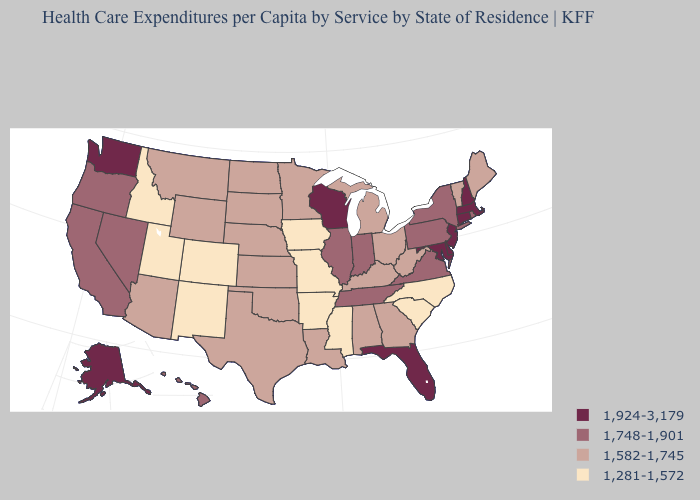Does the first symbol in the legend represent the smallest category?
Write a very short answer. No. Does the map have missing data?
Concise answer only. No. What is the highest value in the USA?
Concise answer only. 1,924-3,179. Which states have the lowest value in the Northeast?
Write a very short answer. Maine, Vermont. Name the states that have a value in the range 1,582-1,745?
Be succinct. Alabama, Arizona, Georgia, Kansas, Kentucky, Louisiana, Maine, Michigan, Minnesota, Montana, Nebraska, North Dakota, Ohio, Oklahoma, South Dakota, Texas, Vermont, West Virginia, Wyoming. How many symbols are there in the legend?
Concise answer only. 4. What is the highest value in the USA?
Short answer required. 1,924-3,179. Among the states that border Alabama , which have the lowest value?
Quick response, please. Mississippi. What is the value of Washington?
Be succinct. 1,924-3,179. What is the lowest value in the USA?
Short answer required. 1,281-1,572. What is the lowest value in the USA?
Write a very short answer. 1,281-1,572. What is the value of Texas?
Quick response, please. 1,582-1,745. Is the legend a continuous bar?
Give a very brief answer. No. Name the states that have a value in the range 1,281-1,572?
Give a very brief answer. Arkansas, Colorado, Idaho, Iowa, Mississippi, Missouri, New Mexico, North Carolina, South Carolina, Utah. What is the value of Pennsylvania?
Give a very brief answer. 1,748-1,901. 